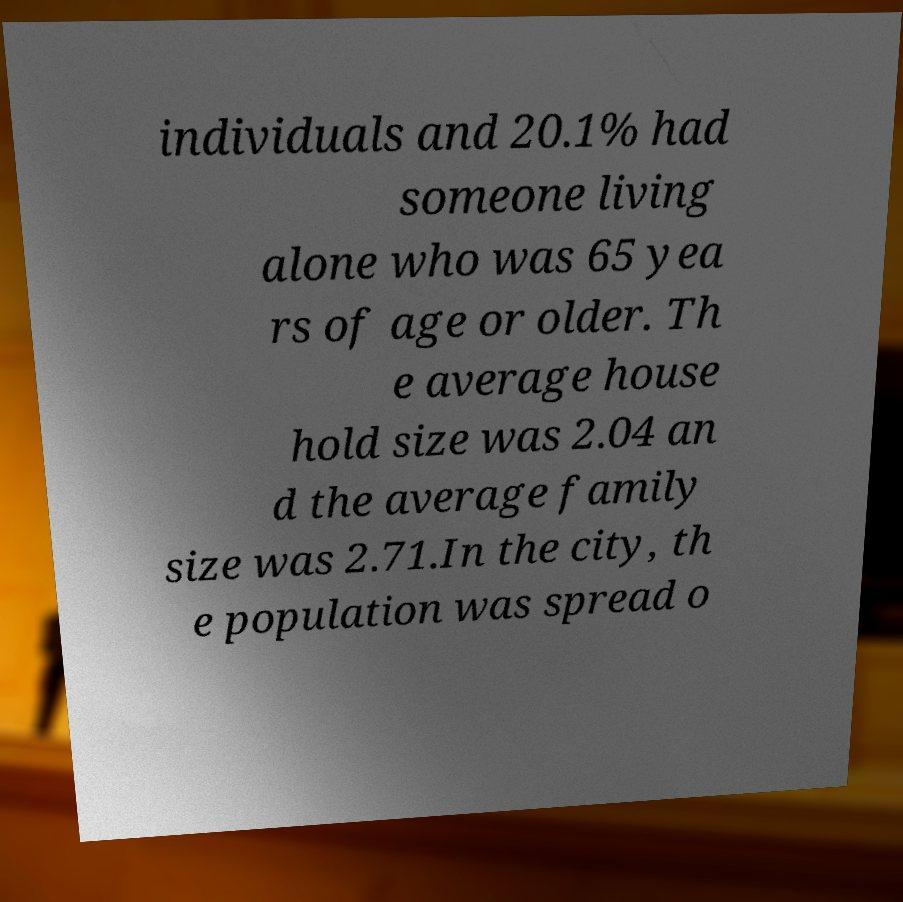There's text embedded in this image that I need extracted. Can you transcribe it verbatim? individuals and 20.1% had someone living alone who was 65 yea rs of age or older. Th e average house hold size was 2.04 an d the average family size was 2.71.In the city, th e population was spread o 